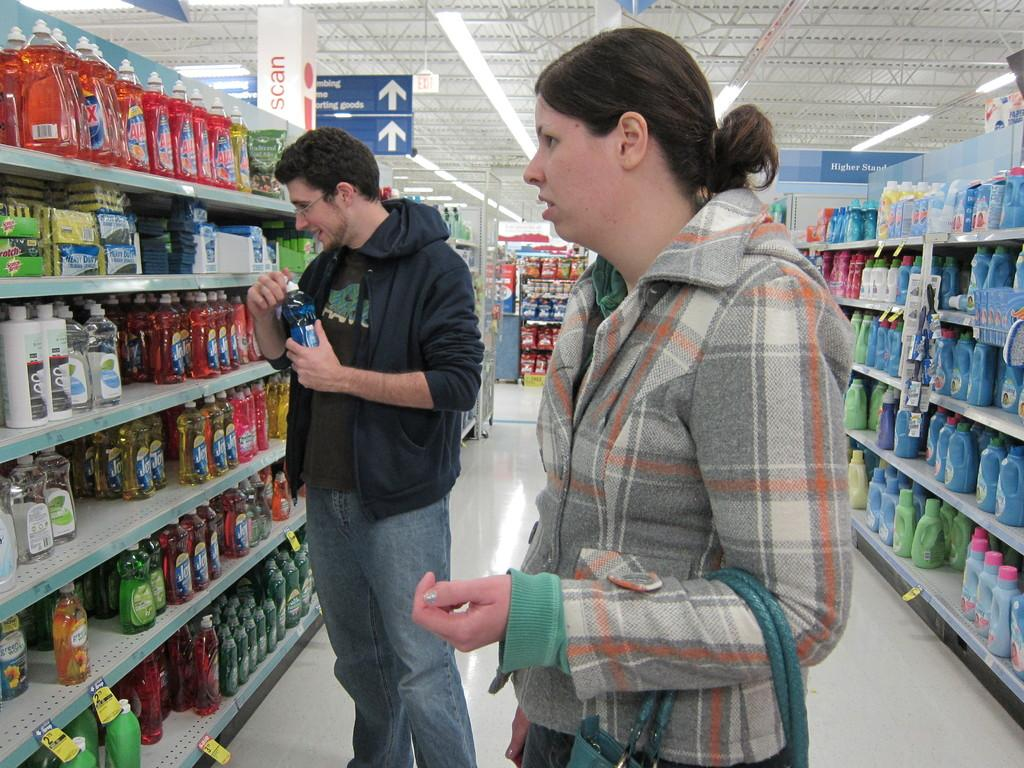Provide a one-sentence caption for the provided image. A man stands in front of shelves full of bottles of Ajax and Dawn and other dish soaps. 